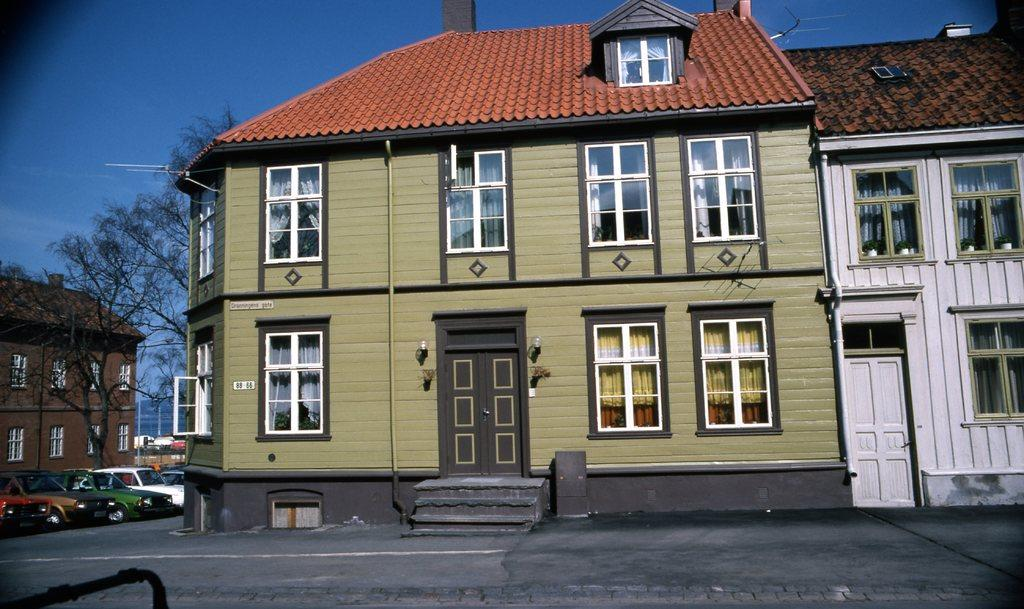What type of structures are present in the image? There are buildings with windows, doors, and lights in the image. What architectural feature is present in front of the buildings? There are steps in front of the buildings. What can be seen on the left side of the image? There are vehicles and trees on the left side of the image. What is visible in the background of the image? The sky is visible in the background of the image. What type of neck can be seen on the trees in the image? There are no necks present on the trees in the image, as trees do not have necks. What is the stem used for in the image? There are no stems present in the image, as the provided facts do not mention any stems. 